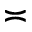Convert formula to latex. <formula><loc_0><loc_0><loc_500><loc_500>\asymp</formula> 